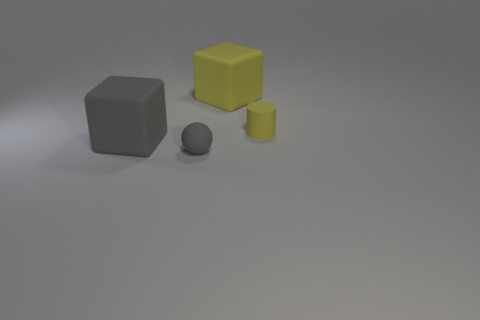Can you describe the size relationship between the objects? Certainly! In the image, there is a gray cube that is the largest object. The yellow cube is slightly smaller, and the yellow cylinder is the smallest in height but similar in diameter to the sphere, which is the smallest object in width. 